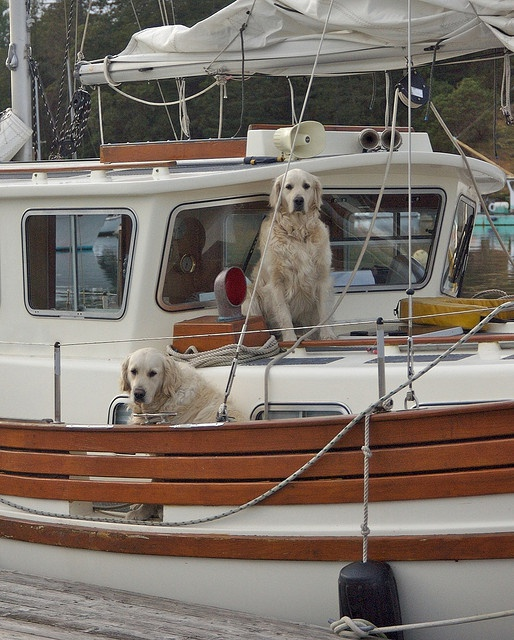Describe the objects in this image and their specific colors. I can see boat in darkgray, gray, black, maroon, and darkgreen tones, dog in darkgreen, gray, and darkgray tones, dog in darkgreen, darkgray, and gray tones, and clock in darkgreen, black, and gray tones in this image. 